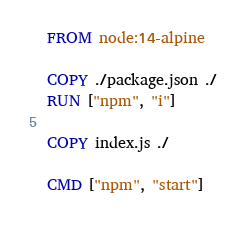Convert code to text. <code><loc_0><loc_0><loc_500><loc_500><_Dockerfile_>FROM node:14-alpine

COPY ./package.json ./
RUN ["npm", "i"]

COPY index.js ./

CMD ["npm", "start"]
</code> 